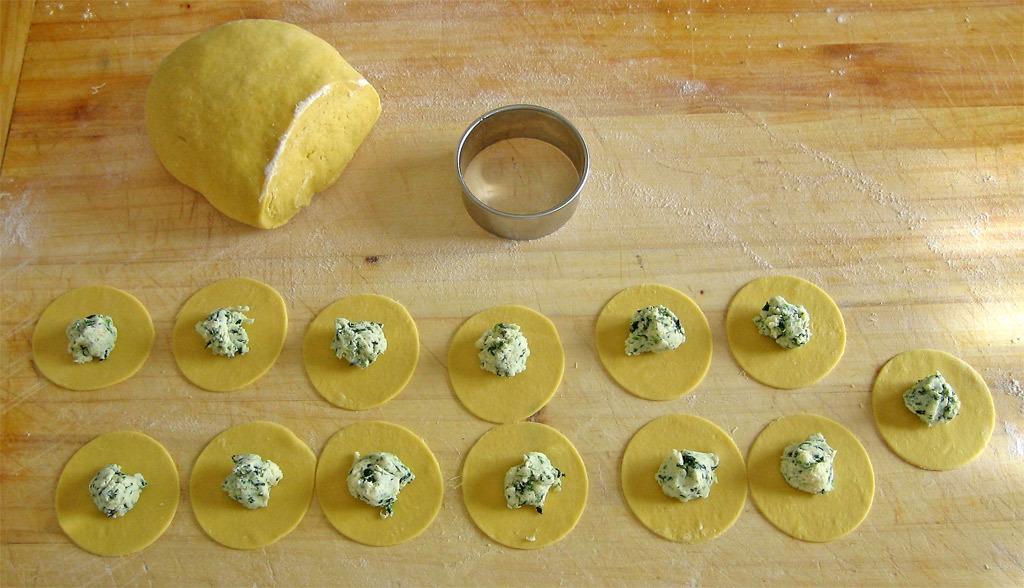Can you describe this image briefly? At the bottom of this image, there are food items arranged on a surface. At the top of this image, there is a food item and a steel object placed on the surface. And the background is brown in color. 